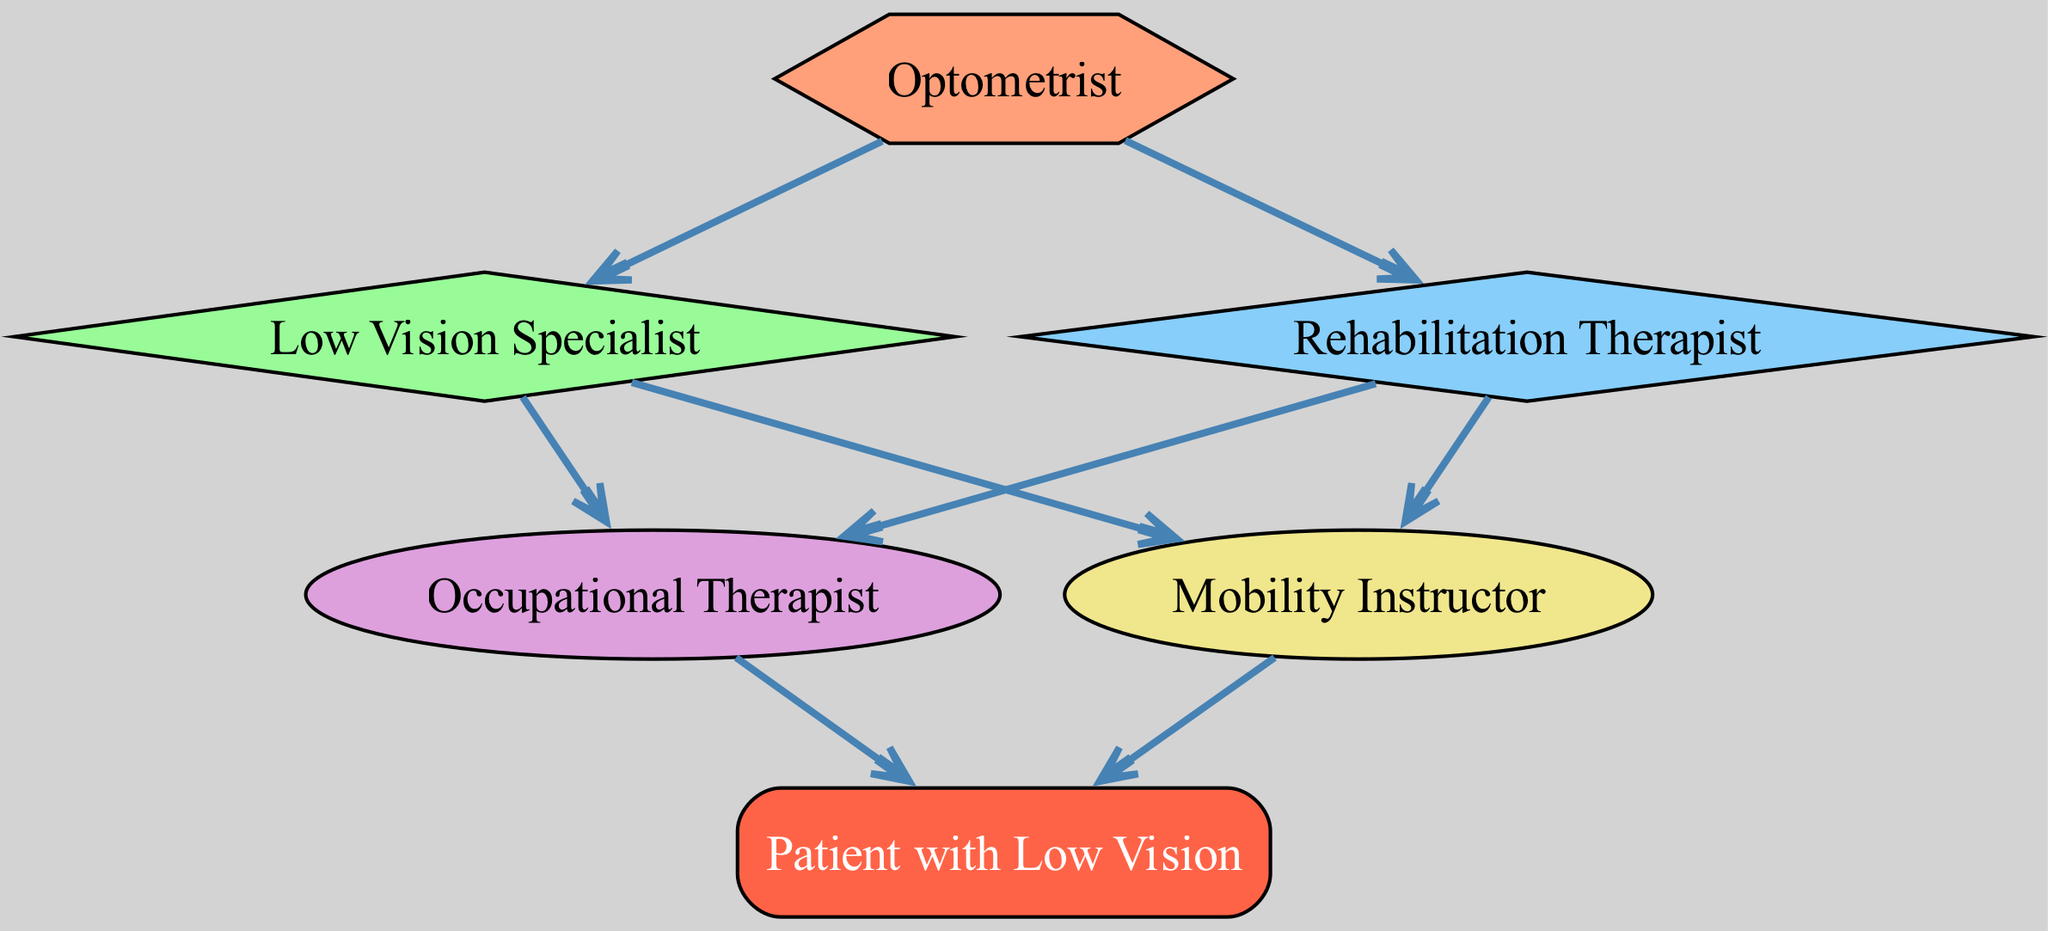What are the main professional roles involved in the low vision rehabilitation process? The diagram lists several roles involved, including Optometrist, Low Vision Specialist, Rehabilitation Therapist, Occupational Therapist, and Mobility Instructor.
Answer: Optometrist, Low Vision Specialist, Rehabilitation Therapist, Occupational Therapist, Mobility Instructor How many connections does the Rehabilitation Therapist have? By examining the diagram, the Rehabilitation Therapist connects to two nodes: Low Vision Specialist and Mobility Instructor, indicating two connections.
Answer: 2 Which role directly connects to the Patient with Low Vision? Following the arrows in the diagram, both Occupational Therapist and Mobility Instructor connect to the Patient with Low Vision, meaning they are the roles providing services to the patient.
Answer: Occupational Therapist, Mobility Instructor What shape represents the Optometrist in the diagram? The diagram specifies the shape for the Optometrist role as a hexagon, which is distinct from the other roles.
Answer: Hexagon Who is at the end of the rehabilitation food chain? The final node in the diagram is the Patient with Low Vision, indicating that all other roles feed their expertise into aiding the patient.
Answer: Patient with Low Vision Which role is linked to both the Low Vision Specialist and the Rehabilitation Therapist? The diagram shows that both the Low Vision Specialist and the Rehabilitation Therapist connect to the same two following roles: Occupational Therapist and Mobility Instructor, indicating a collaborative approach.
Answer: Occupational Therapist, Mobility Instructor How many total roles are depicted in the diagram? Counting all the unique roles present in the diagram results in a total of six distinct roles that contribute to the low vision rehabilitation process.
Answer: 6 What type of diagram is being illustrated? The diagram represents a Food Chain concerning multidisciplinary approaches in low vision rehabilitation, showing how different roles interact to support the patient.
Answer: Food Chain 